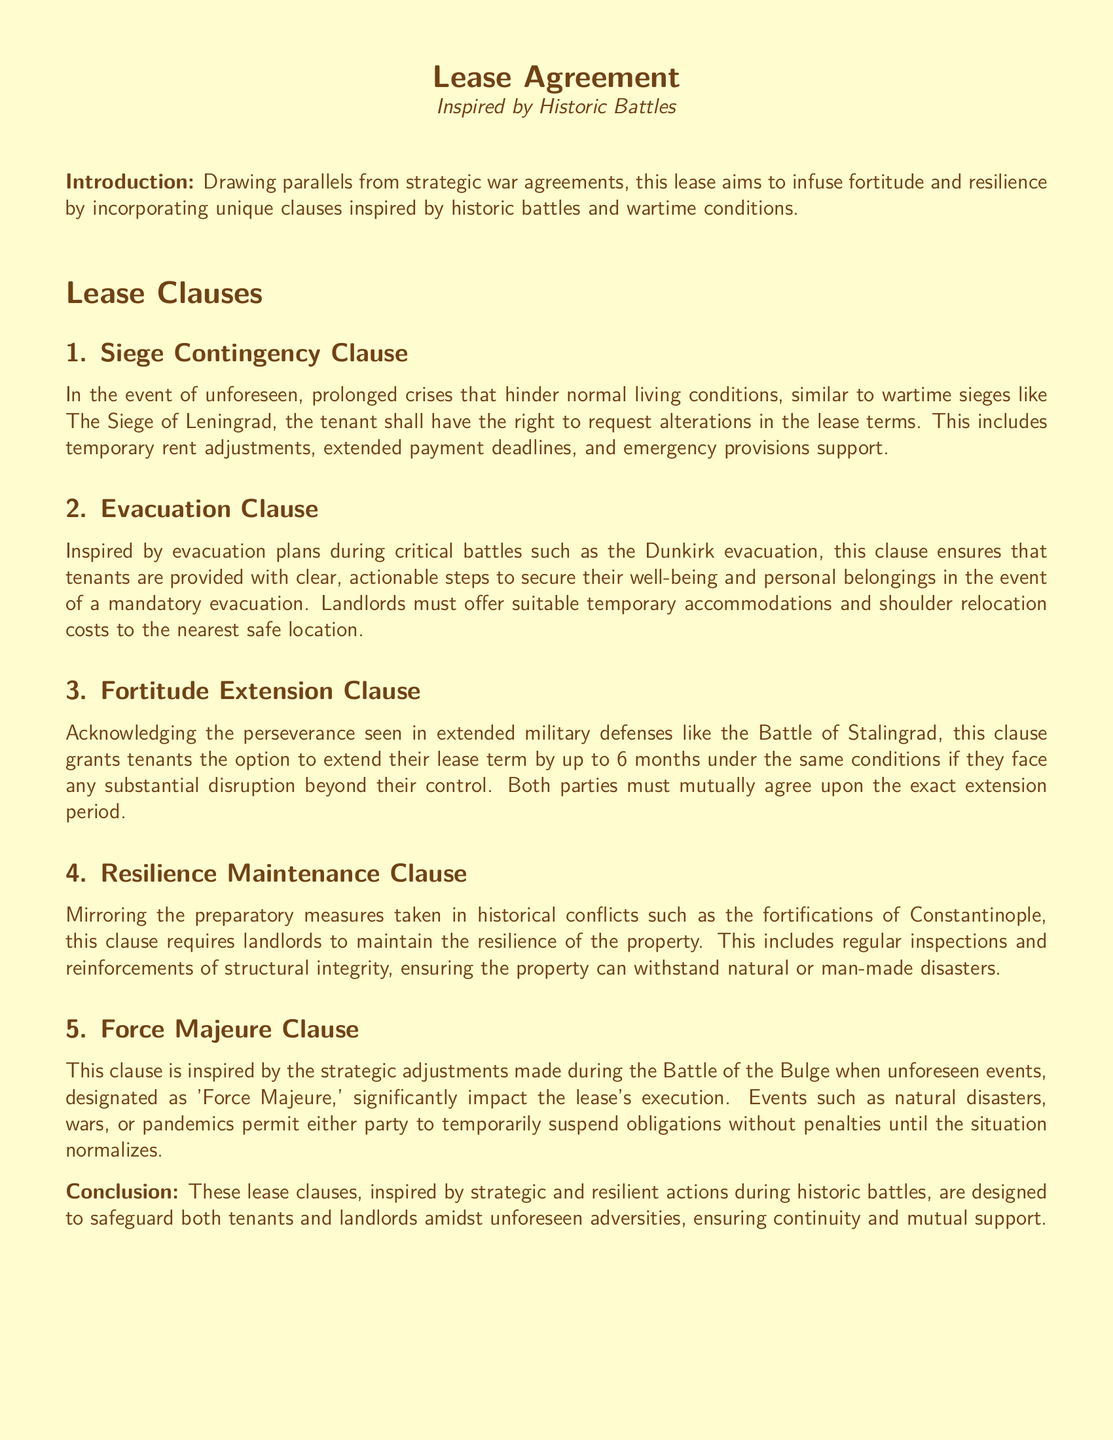What is the title of the document? The title of the document is prominently displayed at the top and is "Lease Agreement."
Answer: Lease Agreement What historic battle is the "Siege Contingency Clause" inspired by? The "Siege Contingency Clause" references a specific historic event compared to a siege, which is The Siege of Leningrad.
Answer: The Siege of Leningrad How long can tenants extend their lease term under the "Fortitude Extension Clause"? The document mentions that tenants have the option to extend their lease term by up to 6 months under certain conditions.
Answer: 6 months What does the "Evacuation Clause" provide for tenants? The clause outlines the obligation of landlords to ensure tenant safety in case of an emergency, which includes clear, actionable steps and temporary accommodations.
Answer: Temporary accommodations What is required of landlords in the "Resilience Maintenance Clause"? The clause mandates that landlords regularly inspect and reinforce the structural integrity of the property to maintain its resilience.
Answer: Regular inspections What does "Force Majeure" specifically relate to? The document refers to Force Majeure as unforeseen events that impact the execution of the lease, specifically mentioning natural disasters, wars, or pandemics.
Answer: Natural disasters, wars, or pandemics What is emphasized in the lease agreement's introduction? The introduction highlights the infusion of fortitude and resilience into the lease agreement by drawing parallels from strategic war agreements.
Answer: Fortitude and resilience Who must mutually agree upon the extension period in the "Fortitude Extension Clause"? The document specifies that both parties involved in the lease agreement must agree on the exact extension period.
Answer: Both parties What is the document inspired by? The lease agreement draws inspiration from historical battles and wartime conditions to establish its clauses.
Answer: Historical battles and wartime conditions 